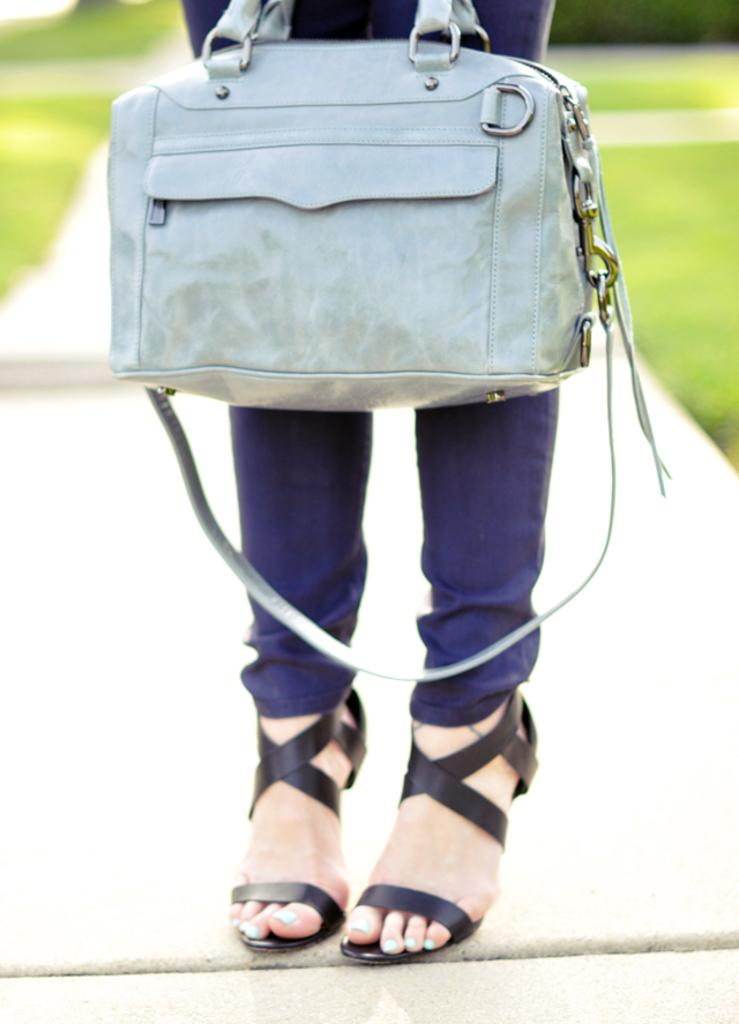What object is being carried by the woman in the image? There is a bag in the image, and a woman is carrying it. Can you describe the woman carrying the bag? The provided facts do not give any information about the woman's appearance or clothing. What might be inside the bag? The contents of the bag are not visible in the image, so it cannot be determined what might be inside. Where is the nearest zoo to the location of the image? The provided facts do not give any information about the location of the image, so it cannot be determined where the nearest zoo is. What time is displayed on the clock in the image? There is no clock present in the image, so it cannot be determined what time is displayed. 